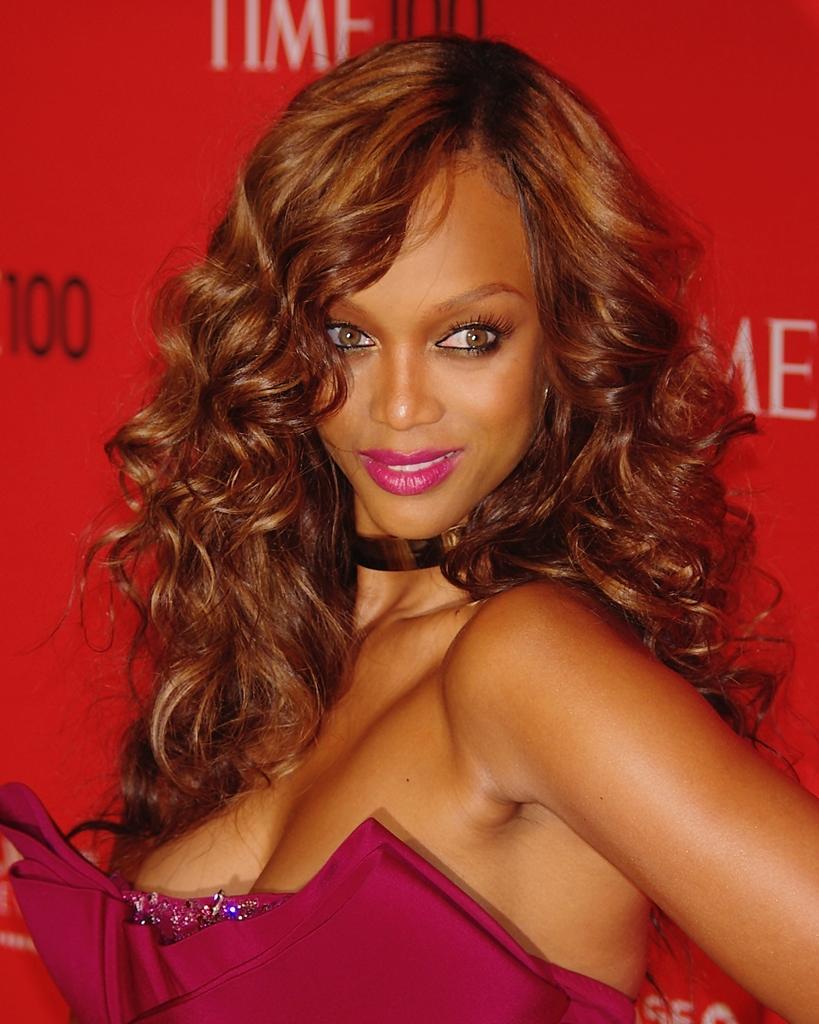Describe this image in one or two sentences. In this picture, we see a woman is standing. He is smiling and she might be posing for the photo. Behind her, we see a board or a banner in red color with some text written on it. 